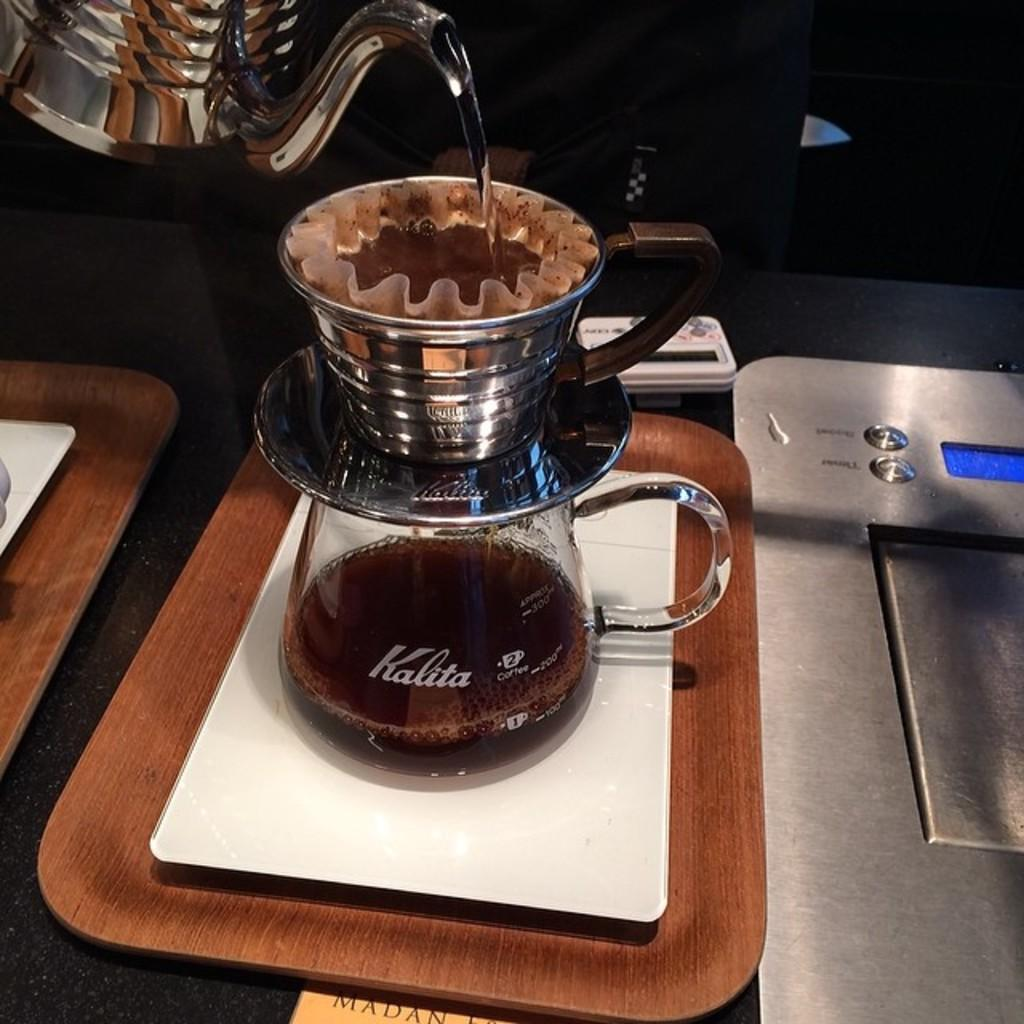What is the main object in the image? There is a kettle in the image. What other objects can be seen in the image? There is a glass bowl, a tray, a cup on top of the bowl, and another tray on the left side of the image. What rule does the mom enforce in the image? There is no mention of a mom or any rules in the image. The image only shows a kettle, a glass bowl, a tray, a cup on top of the bowl, and another tray on the left side of the image. 